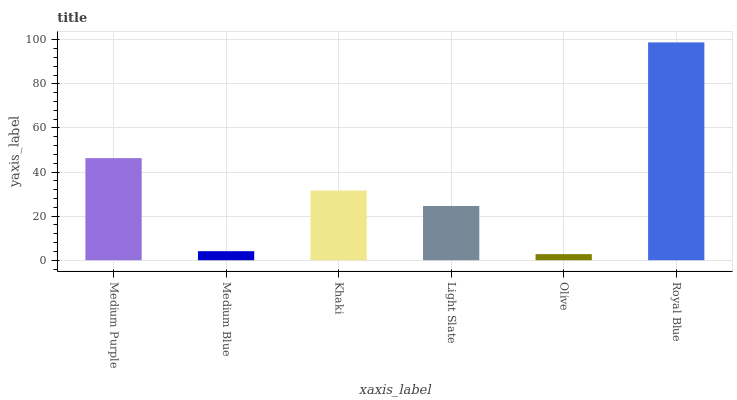Is Olive the minimum?
Answer yes or no. Yes. Is Royal Blue the maximum?
Answer yes or no. Yes. Is Medium Blue the minimum?
Answer yes or no. No. Is Medium Blue the maximum?
Answer yes or no. No. Is Medium Purple greater than Medium Blue?
Answer yes or no. Yes. Is Medium Blue less than Medium Purple?
Answer yes or no. Yes. Is Medium Blue greater than Medium Purple?
Answer yes or no. No. Is Medium Purple less than Medium Blue?
Answer yes or no. No. Is Khaki the high median?
Answer yes or no. Yes. Is Light Slate the low median?
Answer yes or no. Yes. Is Royal Blue the high median?
Answer yes or no. No. Is Royal Blue the low median?
Answer yes or no. No. 